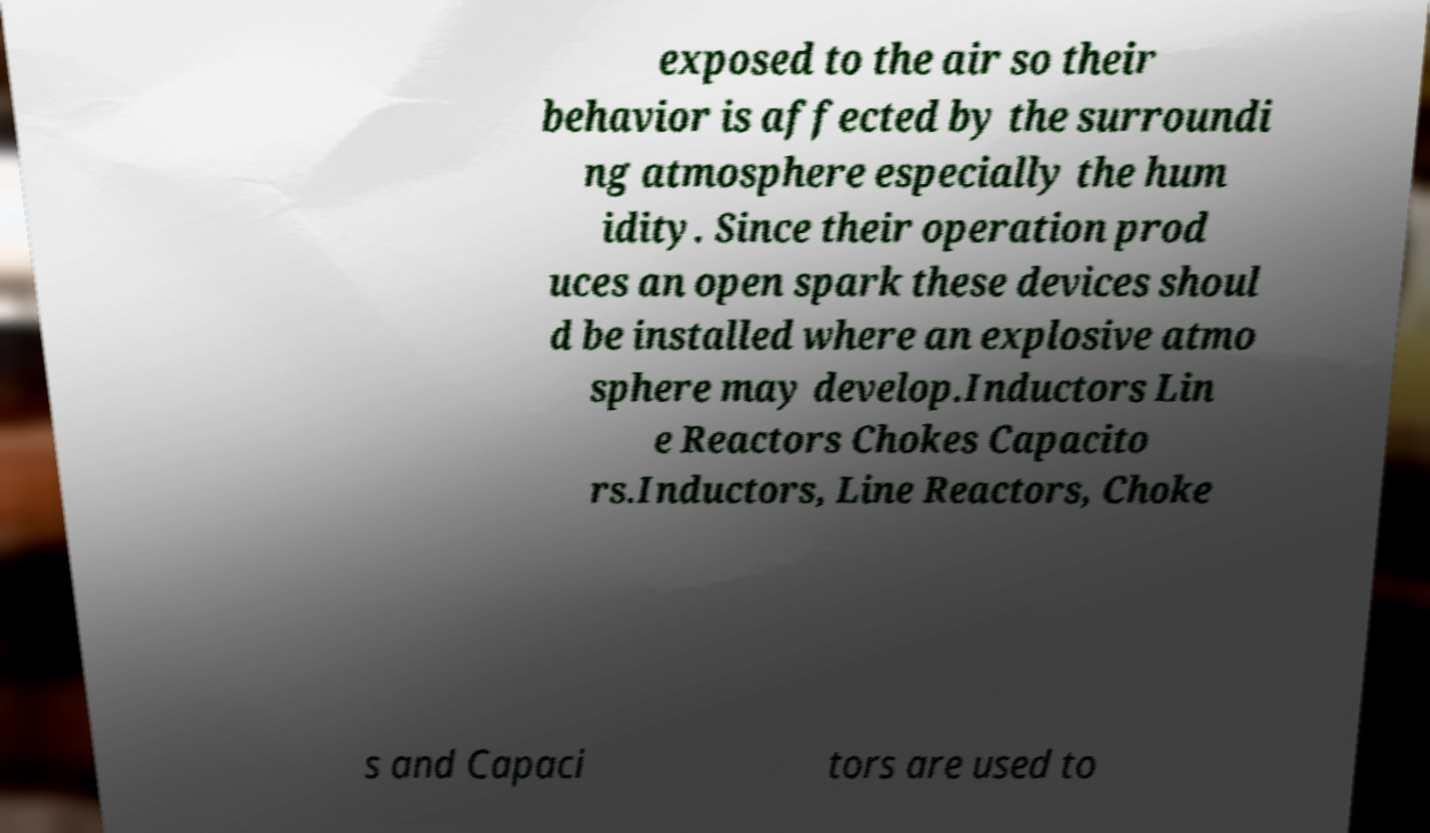Can you accurately transcribe the text from the provided image for me? exposed to the air so their behavior is affected by the surroundi ng atmosphere especially the hum idity. Since their operation prod uces an open spark these devices shoul d be installed where an explosive atmo sphere may develop.Inductors Lin e Reactors Chokes Capacito rs.Inductors, Line Reactors, Choke s and Capaci tors are used to 